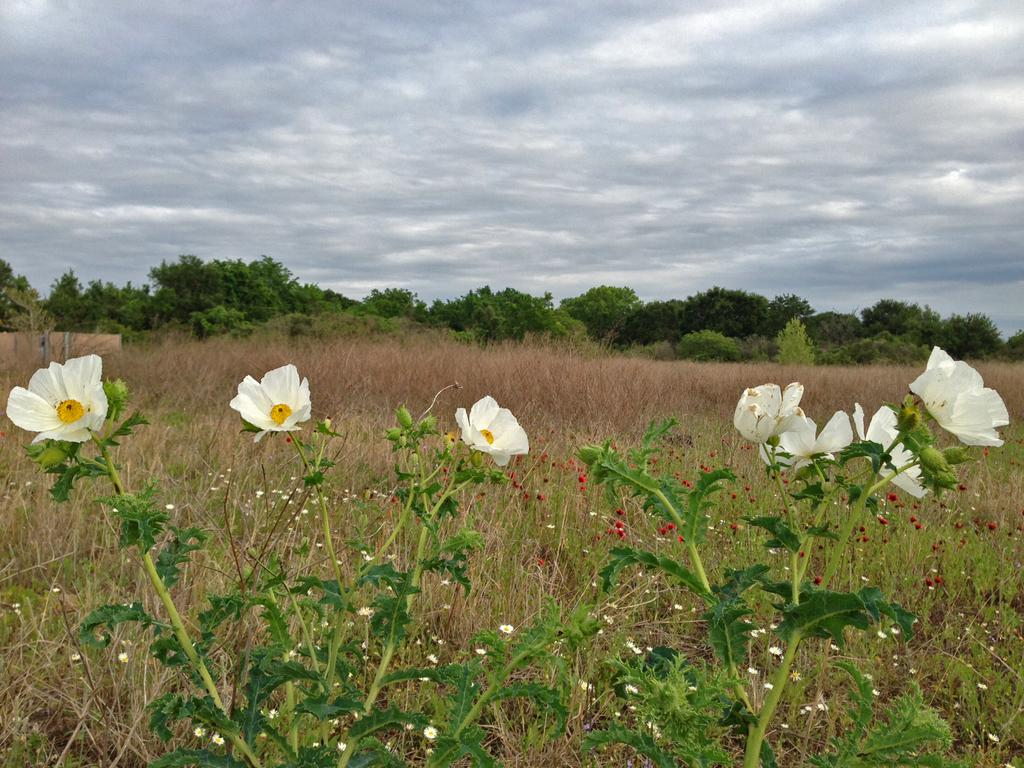What is the main subject in the center of the image? There are flower plants in the center of the image. What can be seen in the background of the image? There are trees in the background of the image. How many pies are hanging from the flower plants in the image? There are no pies present in the image; it features flower plants and trees. What type of root can be seen growing from the flower plants in the image? There is no root visible in the image; only the flower plants and trees are present. 